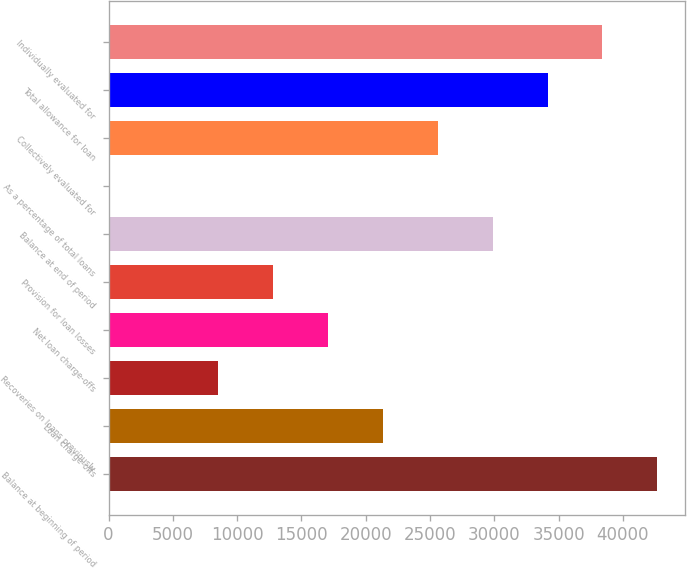Convert chart to OTSL. <chart><loc_0><loc_0><loc_500><loc_500><bar_chart><fcel>Balance at beginning of period<fcel>Loan charge-offs<fcel>Recoveries on loans previously<fcel>Net loan charge-offs<fcel>Provision for loan losses<fcel>Balance at end of period<fcel>As a percentage of total loans<fcel>Collectively evaluated for<fcel>Total allowance for loan<fcel>Individually evaluated for<nl><fcel>42679<fcel>21340.3<fcel>8537.16<fcel>17072.6<fcel>12804.9<fcel>29875.8<fcel>1.7<fcel>25608.1<fcel>34143.5<fcel>38411.3<nl></chart> 